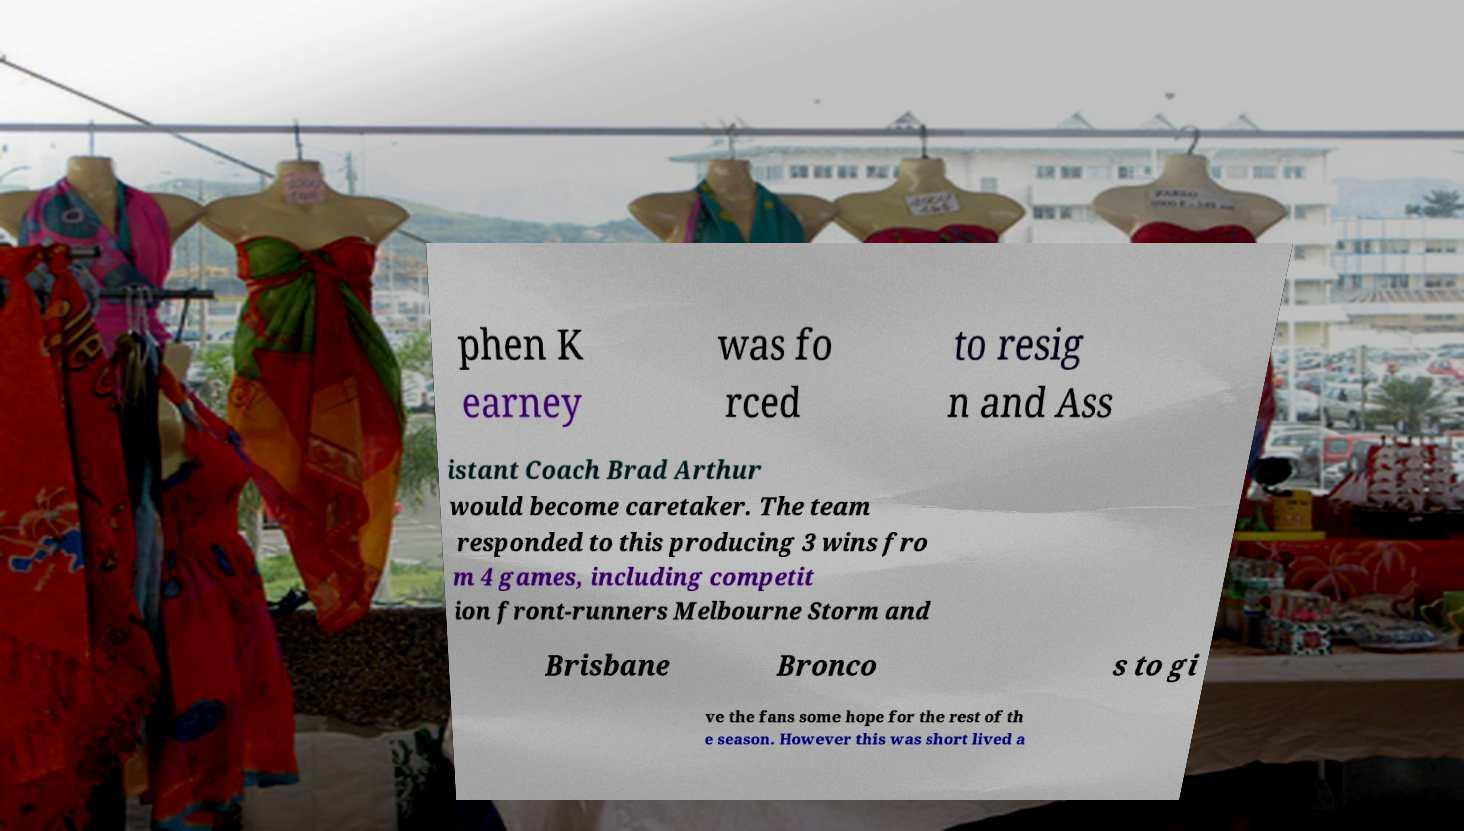Could you assist in decoding the text presented in this image and type it out clearly? phen K earney was fo rced to resig n and Ass istant Coach Brad Arthur would become caretaker. The team responded to this producing 3 wins fro m 4 games, including competit ion front-runners Melbourne Storm and Brisbane Bronco s to gi ve the fans some hope for the rest of th e season. However this was short lived a 